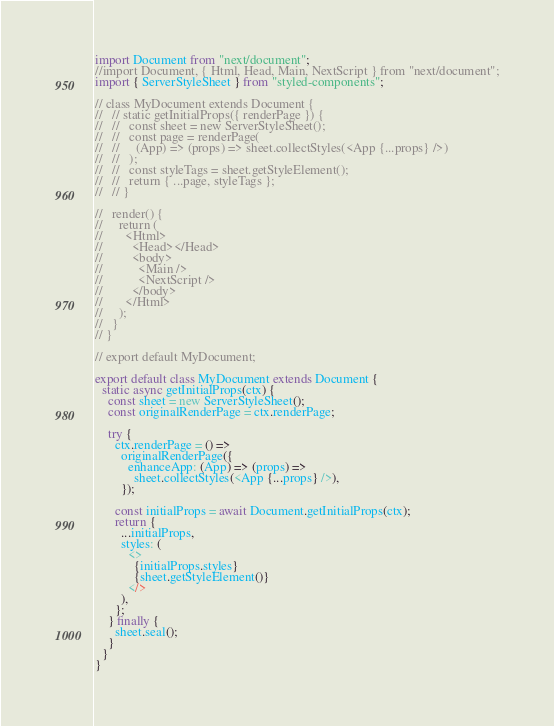<code> <loc_0><loc_0><loc_500><loc_500><_TypeScript_>import Document from "next/document";
//import Document, { Html, Head, Main, NextScript } from "next/document";
import { ServerStyleSheet } from "styled-components";

// class MyDocument extends Document {
//   // static getInitialProps({ renderPage }) {
//   //   const sheet = new ServerStyleSheet();
//   //   const page = renderPage(
//   //     (App) => (props) => sheet.collectStyles(<App {...props} />)
//   //   );
//   //   const styleTags = sheet.getStyleElement();
//   //   return { ...page, styleTags };
//   // }

//   render() {
//     return (
//       <Html>
//         <Head></Head>
//         <body>
//           <Main />
//           <NextScript />
//         </body>
//       </Html>
//     );
//   }
// }

// export default MyDocument;

export default class MyDocument extends Document {
  static async getInitialProps(ctx) {
    const sheet = new ServerStyleSheet();
    const originalRenderPage = ctx.renderPage;

    try {
      ctx.renderPage = () =>
        originalRenderPage({
          enhanceApp: (App) => (props) =>
            sheet.collectStyles(<App {...props} />),
        });

      const initialProps = await Document.getInitialProps(ctx);
      return {
        ...initialProps,
        styles: (
          <>
            {initialProps.styles}
            {sheet.getStyleElement()}
          </>
        ),
      };
    } finally {
      sheet.seal();
    }
  }
}
</code> 